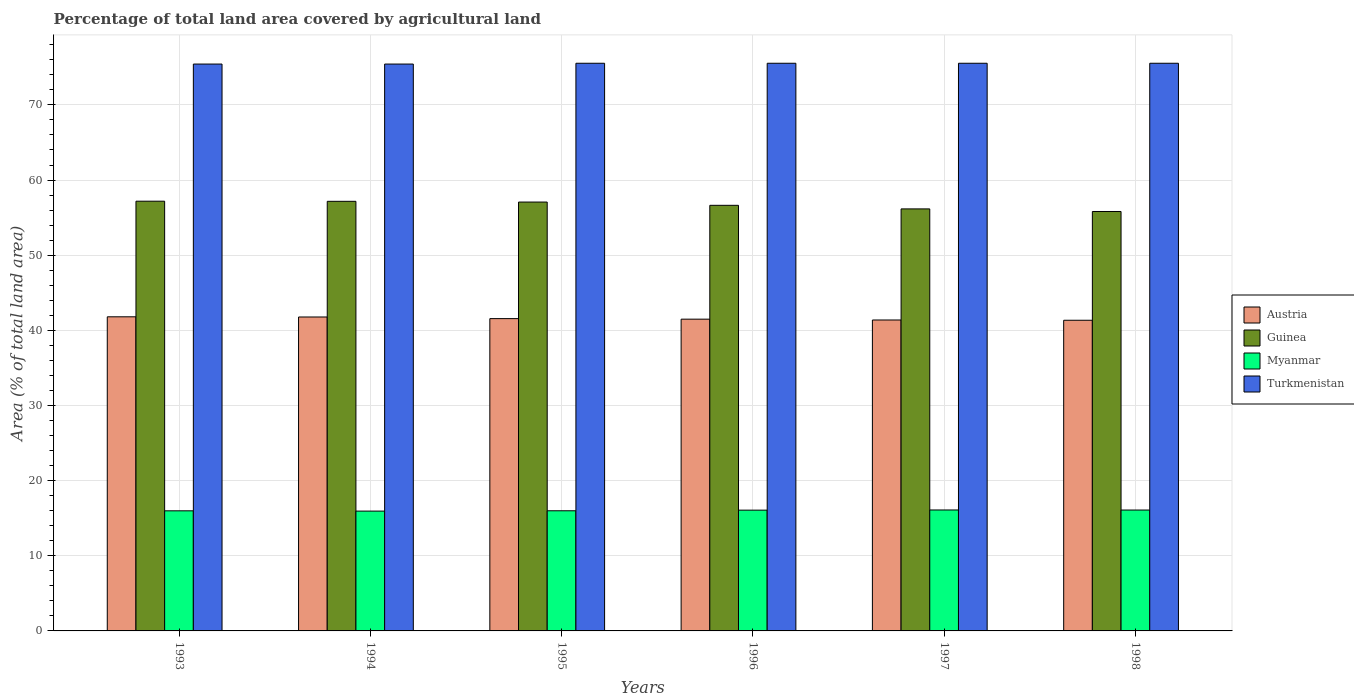How many different coloured bars are there?
Make the answer very short. 4. Are the number of bars per tick equal to the number of legend labels?
Offer a very short reply. Yes. What is the label of the 5th group of bars from the left?
Provide a short and direct response. 1997. In how many cases, is the number of bars for a given year not equal to the number of legend labels?
Your response must be concise. 0. What is the percentage of agricultural land in Turkmenistan in 1996?
Keep it short and to the point. 75.54. Across all years, what is the maximum percentage of agricultural land in Turkmenistan?
Your response must be concise. 75.54. Across all years, what is the minimum percentage of agricultural land in Austria?
Make the answer very short. 41.34. In which year was the percentage of agricultural land in Turkmenistan minimum?
Your response must be concise. 1993. What is the total percentage of agricultural land in Turkmenistan in the graph?
Your response must be concise. 453.05. What is the difference between the percentage of agricultural land in Austria in 1994 and that in 1998?
Give a very brief answer. 0.44. What is the difference between the percentage of agricultural land in Turkmenistan in 1998 and the percentage of agricultural land in Guinea in 1994?
Make the answer very short. 18.37. What is the average percentage of agricultural land in Turkmenistan per year?
Give a very brief answer. 75.51. In the year 1996, what is the difference between the percentage of agricultural land in Guinea and percentage of agricultural land in Austria?
Your answer should be compact. 15.15. In how many years, is the percentage of agricultural land in Guinea greater than 2 %?
Provide a succinct answer. 6. What is the ratio of the percentage of agricultural land in Guinea in 1997 to that in 1998?
Provide a short and direct response. 1.01. Is the percentage of agricultural land in Guinea in 1997 less than that in 1998?
Your answer should be very brief. No. What is the difference between the highest and the second highest percentage of agricultural land in Turkmenistan?
Your answer should be very brief. 0. What is the difference between the highest and the lowest percentage of agricultural land in Turkmenistan?
Give a very brief answer. 0.11. In how many years, is the percentage of agricultural land in Myanmar greater than the average percentage of agricultural land in Myanmar taken over all years?
Offer a terse response. 3. Is the sum of the percentage of agricultural land in Myanmar in 1993 and 1998 greater than the maximum percentage of agricultural land in Turkmenistan across all years?
Provide a short and direct response. No. Is it the case that in every year, the sum of the percentage of agricultural land in Guinea and percentage of agricultural land in Austria is greater than the sum of percentage of agricultural land in Turkmenistan and percentage of agricultural land in Myanmar?
Your response must be concise. Yes. What does the 2nd bar from the left in 1995 represents?
Your answer should be compact. Guinea. What does the 3rd bar from the right in 1998 represents?
Provide a succinct answer. Guinea. How many bars are there?
Your answer should be compact. 24. How many years are there in the graph?
Offer a terse response. 6. What is the difference between two consecutive major ticks on the Y-axis?
Ensure brevity in your answer.  10. Does the graph contain any zero values?
Provide a succinct answer. No. Does the graph contain grids?
Your answer should be compact. Yes. Where does the legend appear in the graph?
Offer a terse response. Center right. How many legend labels are there?
Give a very brief answer. 4. How are the legend labels stacked?
Provide a succinct answer. Vertical. What is the title of the graph?
Give a very brief answer. Percentage of total land area covered by agricultural land. What is the label or title of the X-axis?
Provide a short and direct response. Years. What is the label or title of the Y-axis?
Offer a terse response. Area (% of total land area). What is the Area (% of total land area) in Austria in 1993?
Offer a very short reply. 41.8. What is the Area (% of total land area) of Guinea in 1993?
Your answer should be very brief. 57.19. What is the Area (% of total land area) in Myanmar in 1993?
Keep it short and to the point. 15.98. What is the Area (% of total land area) of Turkmenistan in 1993?
Offer a terse response. 75.44. What is the Area (% of total land area) of Austria in 1994?
Provide a succinct answer. 41.78. What is the Area (% of total land area) of Guinea in 1994?
Your answer should be compact. 57.17. What is the Area (% of total land area) in Myanmar in 1994?
Your response must be concise. 15.95. What is the Area (% of total land area) of Turkmenistan in 1994?
Ensure brevity in your answer.  75.44. What is the Area (% of total land area) in Austria in 1995?
Your response must be concise. 41.56. What is the Area (% of total land area) of Guinea in 1995?
Your answer should be very brief. 57.07. What is the Area (% of total land area) of Myanmar in 1995?
Your answer should be compact. 15.99. What is the Area (% of total land area) of Turkmenistan in 1995?
Provide a short and direct response. 75.54. What is the Area (% of total land area) of Austria in 1996?
Provide a short and direct response. 41.49. What is the Area (% of total land area) of Guinea in 1996?
Offer a very short reply. 56.64. What is the Area (% of total land area) in Myanmar in 1996?
Offer a terse response. 16.07. What is the Area (% of total land area) of Turkmenistan in 1996?
Provide a succinct answer. 75.54. What is the Area (% of total land area) of Austria in 1997?
Offer a very short reply. 41.38. What is the Area (% of total land area) in Guinea in 1997?
Provide a short and direct response. 56.16. What is the Area (% of total land area) in Myanmar in 1997?
Make the answer very short. 16.1. What is the Area (% of total land area) in Turkmenistan in 1997?
Give a very brief answer. 75.54. What is the Area (% of total land area) of Austria in 1998?
Your answer should be very brief. 41.34. What is the Area (% of total land area) of Guinea in 1998?
Provide a succinct answer. 55.82. What is the Area (% of total land area) of Myanmar in 1998?
Give a very brief answer. 16.09. What is the Area (% of total land area) of Turkmenistan in 1998?
Provide a succinct answer. 75.54. Across all years, what is the maximum Area (% of total land area) in Austria?
Your answer should be compact. 41.8. Across all years, what is the maximum Area (% of total land area) of Guinea?
Offer a terse response. 57.19. Across all years, what is the maximum Area (% of total land area) of Myanmar?
Provide a succinct answer. 16.1. Across all years, what is the maximum Area (% of total land area) in Turkmenistan?
Make the answer very short. 75.54. Across all years, what is the minimum Area (% of total land area) in Austria?
Your answer should be very brief. 41.34. Across all years, what is the minimum Area (% of total land area) in Guinea?
Your response must be concise. 55.82. Across all years, what is the minimum Area (% of total land area) in Myanmar?
Your answer should be very brief. 15.95. Across all years, what is the minimum Area (% of total land area) in Turkmenistan?
Offer a terse response. 75.44. What is the total Area (% of total land area) in Austria in the graph?
Your answer should be compact. 249.35. What is the total Area (% of total land area) in Guinea in the graph?
Your answer should be very brief. 340.05. What is the total Area (% of total land area) in Myanmar in the graph?
Offer a very short reply. 96.17. What is the total Area (% of total land area) in Turkmenistan in the graph?
Your answer should be compact. 453.05. What is the difference between the Area (% of total land area) of Austria in 1993 and that in 1994?
Keep it short and to the point. 0.02. What is the difference between the Area (% of total land area) of Guinea in 1993 and that in 1994?
Provide a short and direct response. 0.02. What is the difference between the Area (% of total land area) in Myanmar in 1993 and that in 1994?
Make the answer very short. 0.04. What is the difference between the Area (% of total land area) in Austria in 1993 and that in 1995?
Keep it short and to the point. 0.24. What is the difference between the Area (% of total land area) in Guinea in 1993 and that in 1995?
Offer a terse response. 0.11. What is the difference between the Area (% of total land area) of Myanmar in 1993 and that in 1995?
Your response must be concise. -0.01. What is the difference between the Area (% of total land area) in Turkmenistan in 1993 and that in 1995?
Keep it short and to the point. -0.11. What is the difference between the Area (% of total land area) in Austria in 1993 and that in 1996?
Your response must be concise. 0.31. What is the difference between the Area (% of total land area) of Guinea in 1993 and that in 1996?
Ensure brevity in your answer.  0.55. What is the difference between the Area (% of total land area) in Myanmar in 1993 and that in 1996?
Your answer should be very brief. -0.09. What is the difference between the Area (% of total land area) of Turkmenistan in 1993 and that in 1996?
Make the answer very short. -0.11. What is the difference between the Area (% of total land area) of Austria in 1993 and that in 1997?
Offer a terse response. 0.42. What is the difference between the Area (% of total land area) of Guinea in 1993 and that in 1997?
Ensure brevity in your answer.  1.03. What is the difference between the Area (% of total land area) of Myanmar in 1993 and that in 1997?
Keep it short and to the point. -0.11. What is the difference between the Area (% of total land area) in Turkmenistan in 1993 and that in 1997?
Your answer should be very brief. -0.11. What is the difference between the Area (% of total land area) of Austria in 1993 and that in 1998?
Offer a very short reply. 0.46. What is the difference between the Area (% of total land area) of Guinea in 1993 and that in 1998?
Your response must be concise. 1.37. What is the difference between the Area (% of total land area) in Myanmar in 1993 and that in 1998?
Offer a terse response. -0.1. What is the difference between the Area (% of total land area) in Turkmenistan in 1993 and that in 1998?
Your answer should be very brief. -0.11. What is the difference between the Area (% of total land area) in Austria in 1994 and that in 1995?
Provide a succinct answer. 0.22. What is the difference between the Area (% of total land area) in Guinea in 1994 and that in 1995?
Provide a succinct answer. 0.1. What is the difference between the Area (% of total land area) in Myanmar in 1994 and that in 1995?
Offer a very short reply. -0.04. What is the difference between the Area (% of total land area) in Turkmenistan in 1994 and that in 1995?
Your answer should be compact. -0.11. What is the difference between the Area (% of total land area) in Austria in 1994 and that in 1996?
Offer a very short reply. 0.29. What is the difference between the Area (% of total land area) of Guinea in 1994 and that in 1996?
Ensure brevity in your answer.  0.53. What is the difference between the Area (% of total land area) in Myanmar in 1994 and that in 1996?
Offer a terse response. -0.13. What is the difference between the Area (% of total land area) of Turkmenistan in 1994 and that in 1996?
Your answer should be compact. -0.11. What is the difference between the Area (% of total land area) in Austria in 1994 and that in 1997?
Your answer should be compact. 0.4. What is the difference between the Area (% of total land area) in Guinea in 1994 and that in 1997?
Offer a very short reply. 1.01. What is the difference between the Area (% of total land area) in Turkmenistan in 1994 and that in 1997?
Give a very brief answer. -0.11. What is the difference between the Area (% of total land area) in Austria in 1994 and that in 1998?
Your answer should be compact. 0.44. What is the difference between the Area (% of total land area) of Guinea in 1994 and that in 1998?
Your answer should be very brief. 1.36. What is the difference between the Area (% of total land area) in Myanmar in 1994 and that in 1998?
Your answer should be compact. -0.14. What is the difference between the Area (% of total land area) in Turkmenistan in 1994 and that in 1998?
Keep it short and to the point. -0.11. What is the difference between the Area (% of total land area) of Austria in 1995 and that in 1996?
Offer a terse response. 0.07. What is the difference between the Area (% of total land area) in Guinea in 1995 and that in 1996?
Your answer should be very brief. 0.44. What is the difference between the Area (% of total land area) in Myanmar in 1995 and that in 1996?
Ensure brevity in your answer.  -0.08. What is the difference between the Area (% of total land area) of Turkmenistan in 1995 and that in 1996?
Make the answer very short. 0. What is the difference between the Area (% of total land area) in Austria in 1995 and that in 1997?
Offer a terse response. 0.18. What is the difference between the Area (% of total land area) of Guinea in 1995 and that in 1997?
Offer a terse response. 0.91. What is the difference between the Area (% of total land area) in Myanmar in 1995 and that in 1997?
Keep it short and to the point. -0.11. What is the difference between the Area (% of total land area) of Turkmenistan in 1995 and that in 1997?
Ensure brevity in your answer.  0. What is the difference between the Area (% of total land area) of Austria in 1995 and that in 1998?
Provide a short and direct response. 0.22. What is the difference between the Area (% of total land area) in Guinea in 1995 and that in 1998?
Offer a terse response. 1.26. What is the difference between the Area (% of total land area) in Myanmar in 1995 and that in 1998?
Ensure brevity in your answer.  -0.1. What is the difference between the Area (% of total land area) of Turkmenistan in 1995 and that in 1998?
Your response must be concise. 0. What is the difference between the Area (% of total land area) in Austria in 1996 and that in 1997?
Give a very brief answer. 0.11. What is the difference between the Area (% of total land area) of Guinea in 1996 and that in 1997?
Offer a very short reply. 0.48. What is the difference between the Area (% of total land area) of Myanmar in 1996 and that in 1997?
Your response must be concise. -0.02. What is the difference between the Area (% of total land area) in Austria in 1996 and that in 1998?
Provide a succinct answer. 0.15. What is the difference between the Area (% of total land area) of Guinea in 1996 and that in 1998?
Provide a succinct answer. 0.82. What is the difference between the Area (% of total land area) in Myanmar in 1996 and that in 1998?
Provide a succinct answer. -0.01. What is the difference between the Area (% of total land area) in Turkmenistan in 1996 and that in 1998?
Keep it short and to the point. 0. What is the difference between the Area (% of total land area) in Austria in 1997 and that in 1998?
Provide a succinct answer. 0.04. What is the difference between the Area (% of total land area) of Guinea in 1997 and that in 1998?
Your answer should be compact. 0.35. What is the difference between the Area (% of total land area) of Myanmar in 1997 and that in 1998?
Ensure brevity in your answer.  0.01. What is the difference between the Area (% of total land area) of Austria in 1993 and the Area (% of total land area) of Guinea in 1994?
Ensure brevity in your answer.  -15.37. What is the difference between the Area (% of total land area) in Austria in 1993 and the Area (% of total land area) in Myanmar in 1994?
Provide a short and direct response. 25.86. What is the difference between the Area (% of total land area) of Austria in 1993 and the Area (% of total land area) of Turkmenistan in 1994?
Your answer should be very brief. -33.63. What is the difference between the Area (% of total land area) of Guinea in 1993 and the Area (% of total land area) of Myanmar in 1994?
Your response must be concise. 41.24. What is the difference between the Area (% of total land area) of Guinea in 1993 and the Area (% of total land area) of Turkmenistan in 1994?
Your answer should be compact. -18.25. What is the difference between the Area (% of total land area) in Myanmar in 1993 and the Area (% of total land area) in Turkmenistan in 1994?
Offer a very short reply. -59.45. What is the difference between the Area (% of total land area) in Austria in 1993 and the Area (% of total land area) in Guinea in 1995?
Ensure brevity in your answer.  -15.27. What is the difference between the Area (% of total land area) in Austria in 1993 and the Area (% of total land area) in Myanmar in 1995?
Ensure brevity in your answer.  25.81. What is the difference between the Area (% of total land area) of Austria in 1993 and the Area (% of total land area) of Turkmenistan in 1995?
Provide a succinct answer. -33.74. What is the difference between the Area (% of total land area) in Guinea in 1993 and the Area (% of total land area) in Myanmar in 1995?
Provide a succinct answer. 41.2. What is the difference between the Area (% of total land area) in Guinea in 1993 and the Area (% of total land area) in Turkmenistan in 1995?
Provide a succinct answer. -18.36. What is the difference between the Area (% of total land area) in Myanmar in 1993 and the Area (% of total land area) in Turkmenistan in 1995?
Your answer should be compact. -59.56. What is the difference between the Area (% of total land area) of Austria in 1993 and the Area (% of total land area) of Guinea in 1996?
Ensure brevity in your answer.  -14.84. What is the difference between the Area (% of total land area) in Austria in 1993 and the Area (% of total land area) in Myanmar in 1996?
Offer a terse response. 25.73. What is the difference between the Area (% of total land area) in Austria in 1993 and the Area (% of total land area) in Turkmenistan in 1996?
Your answer should be compact. -33.74. What is the difference between the Area (% of total land area) of Guinea in 1993 and the Area (% of total land area) of Myanmar in 1996?
Keep it short and to the point. 41.11. What is the difference between the Area (% of total land area) in Guinea in 1993 and the Area (% of total land area) in Turkmenistan in 1996?
Provide a short and direct response. -18.36. What is the difference between the Area (% of total land area) of Myanmar in 1993 and the Area (% of total land area) of Turkmenistan in 1996?
Keep it short and to the point. -59.56. What is the difference between the Area (% of total land area) in Austria in 1993 and the Area (% of total land area) in Guinea in 1997?
Give a very brief answer. -14.36. What is the difference between the Area (% of total land area) in Austria in 1993 and the Area (% of total land area) in Myanmar in 1997?
Provide a succinct answer. 25.71. What is the difference between the Area (% of total land area) in Austria in 1993 and the Area (% of total land area) in Turkmenistan in 1997?
Ensure brevity in your answer.  -33.74. What is the difference between the Area (% of total land area) of Guinea in 1993 and the Area (% of total land area) of Myanmar in 1997?
Your answer should be very brief. 41.09. What is the difference between the Area (% of total land area) in Guinea in 1993 and the Area (% of total land area) in Turkmenistan in 1997?
Ensure brevity in your answer.  -18.36. What is the difference between the Area (% of total land area) of Myanmar in 1993 and the Area (% of total land area) of Turkmenistan in 1997?
Offer a terse response. -59.56. What is the difference between the Area (% of total land area) of Austria in 1993 and the Area (% of total land area) of Guinea in 1998?
Provide a short and direct response. -14.01. What is the difference between the Area (% of total land area) of Austria in 1993 and the Area (% of total land area) of Myanmar in 1998?
Give a very brief answer. 25.72. What is the difference between the Area (% of total land area) in Austria in 1993 and the Area (% of total land area) in Turkmenistan in 1998?
Offer a very short reply. -33.74. What is the difference between the Area (% of total land area) of Guinea in 1993 and the Area (% of total land area) of Myanmar in 1998?
Provide a short and direct response. 41.1. What is the difference between the Area (% of total land area) of Guinea in 1993 and the Area (% of total land area) of Turkmenistan in 1998?
Provide a succinct answer. -18.36. What is the difference between the Area (% of total land area) in Myanmar in 1993 and the Area (% of total land area) in Turkmenistan in 1998?
Your response must be concise. -59.56. What is the difference between the Area (% of total land area) in Austria in 1994 and the Area (% of total land area) in Guinea in 1995?
Provide a succinct answer. -15.3. What is the difference between the Area (% of total land area) of Austria in 1994 and the Area (% of total land area) of Myanmar in 1995?
Give a very brief answer. 25.79. What is the difference between the Area (% of total land area) of Austria in 1994 and the Area (% of total land area) of Turkmenistan in 1995?
Your answer should be compact. -33.77. What is the difference between the Area (% of total land area) of Guinea in 1994 and the Area (% of total land area) of Myanmar in 1995?
Your answer should be very brief. 41.18. What is the difference between the Area (% of total land area) in Guinea in 1994 and the Area (% of total land area) in Turkmenistan in 1995?
Provide a succinct answer. -18.37. What is the difference between the Area (% of total land area) in Myanmar in 1994 and the Area (% of total land area) in Turkmenistan in 1995?
Make the answer very short. -59.6. What is the difference between the Area (% of total land area) in Austria in 1994 and the Area (% of total land area) in Guinea in 1996?
Offer a very short reply. -14.86. What is the difference between the Area (% of total land area) in Austria in 1994 and the Area (% of total land area) in Myanmar in 1996?
Offer a terse response. 25.71. What is the difference between the Area (% of total land area) of Austria in 1994 and the Area (% of total land area) of Turkmenistan in 1996?
Provide a short and direct response. -33.77. What is the difference between the Area (% of total land area) of Guinea in 1994 and the Area (% of total land area) of Myanmar in 1996?
Give a very brief answer. 41.1. What is the difference between the Area (% of total land area) of Guinea in 1994 and the Area (% of total land area) of Turkmenistan in 1996?
Keep it short and to the point. -18.37. What is the difference between the Area (% of total land area) in Myanmar in 1994 and the Area (% of total land area) in Turkmenistan in 1996?
Keep it short and to the point. -59.6. What is the difference between the Area (% of total land area) of Austria in 1994 and the Area (% of total land area) of Guinea in 1997?
Ensure brevity in your answer.  -14.38. What is the difference between the Area (% of total land area) in Austria in 1994 and the Area (% of total land area) in Myanmar in 1997?
Make the answer very short. 25.68. What is the difference between the Area (% of total land area) in Austria in 1994 and the Area (% of total land area) in Turkmenistan in 1997?
Your answer should be very brief. -33.77. What is the difference between the Area (% of total land area) in Guinea in 1994 and the Area (% of total land area) in Myanmar in 1997?
Provide a succinct answer. 41.08. What is the difference between the Area (% of total land area) of Guinea in 1994 and the Area (% of total land area) of Turkmenistan in 1997?
Offer a terse response. -18.37. What is the difference between the Area (% of total land area) of Myanmar in 1994 and the Area (% of total land area) of Turkmenistan in 1997?
Your response must be concise. -59.6. What is the difference between the Area (% of total land area) of Austria in 1994 and the Area (% of total land area) of Guinea in 1998?
Offer a terse response. -14.04. What is the difference between the Area (% of total land area) of Austria in 1994 and the Area (% of total land area) of Myanmar in 1998?
Keep it short and to the point. 25.69. What is the difference between the Area (% of total land area) in Austria in 1994 and the Area (% of total land area) in Turkmenistan in 1998?
Provide a succinct answer. -33.77. What is the difference between the Area (% of total land area) in Guinea in 1994 and the Area (% of total land area) in Myanmar in 1998?
Your answer should be very brief. 41.08. What is the difference between the Area (% of total land area) in Guinea in 1994 and the Area (% of total land area) in Turkmenistan in 1998?
Offer a terse response. -18.37. What is the difference between the Area (% of total land area) of Myanmar in 1994 and the Area (% of total land area) of Turkmenistan in 1998?
Offer a terse response. -59.6. What is the difference between the Area (% of total land area) of Austria in 1995 and the Area (% of total land area) of Guinea in 1996?
Your answer should be very brief. -15.08. What is the difference between the Area (% of total land area) in Austria in 1995 and the Area (% of total land area) in Myanmar in 1996?
Make the answer very short. 25.49. What is the difference between the Area (% of total land area) in Austria in 1995 and the Area (% of total land area) in Turkmenistan in 1996?
Keep it short and to the point. -33.98. What is the difference between the Area (% of total land area) of Guinea in 1995 and the Area (% of total land area) of Myanmar in 1996?
Give a very brief answer. 41. What is the difference between the Area (% of total land area) in Guinea in 1995 and the Area (% of total land area) in Turkmenistan in 1996?
Give a very brief answer. -18.47. What is the difference between the Area (% of total land area) in Myanmar in 1995 and the Area (% of total land area) in Turkmenistan in 1996?
Offer a very short reply. -59.55. What is the difference between the Area (% of total land area) in Austria in 1995 and the Area (% of total land area) in Guinea in 1997?
Provide a succinct answer. -14.6. What is the difference between the Area (% of total land area) of Austria in 1995 and the Area (% of total land area) of Myanmar in 1997?
Your response must be concise. 25.46. What is the difference between the Area (% of total land area) in Austria in 1995 and the Area (% of total land area) in Turkmenistan in 1997?
Your response must be concise. -33.98. What is the difference between the Area (% of total land area) in Guinea in 1995 and the Area (% of total land area) in Myanmar in 1997?
Provide a short and direct response. 40.98. What is the difference between the Area (% of total land area) in Guinea in 1995 and the Area (% of total land area) in Turkmenistan in 1997?
Your answer should be very brief. -18.47. What is the difference between the Area (% of total land area) of Myanmar in 1995 and the Area (% of total land area) of Turkmenistan in 1997?
Keep it short and to the point. -59.55. What is the difference between the Area (% of total land area) in Austria in 1995 and the Area (% of total land area) in Guinea in 1998?
Provide a short and direct response. -14.26. What is the difference between the Area (% of total land area) in Austria in 1995 and the Area (% of total land area) in Myanmar in 1998?
Provide a succinct answer. 25.47. What is the difference between the Area (% of total land area) in Austria in 1995 and the Area (% of total land area) in Turkmenistan in 1998?
Your response must be concise. -33.98. What is the difference between the Area (% of total land area) of Guinea in 1995 and the Area (% of total land area) of Myanmar in 1998?
Your response must be concise. 40.99. What is the difference between the Area (% of total land area) of Guinea in 1995 and the Area (% of total land area) of Turkmenistan in 1998?
Your answer should be compact. -18.47. What is the difference between the Area (% of total land area) in Myanmar in 1995 and the Area (% of total land area) in Turkmenistan in 1998?
Ensure brevity in your answer.  -59.55. What is the difference between the Area (% of total land area) of Austria in 1996 and the Area (% of total land area) of Guinea in 1997?
Provide a short and direct response. -14.67. What is the difference between the Area (% of total land area) in Austria in 1996 and the Area (% of total land area) in Myanmar in 1997?
Keep it short and to the point. 25.39. What is the difference between the Area (% of total land area) in Austria in 1996 and the Area (% of total land area) in Turkmenistan in 1997?
Your answer should be very brief. -34.06. What is the difference between the Area (% of total land area) of Guinea in 1996 and the Area (% of total land area) of Myanmar in 1997?
Give a very brief answer. 40.54. What is the difference between the Area (% of total land area) of Guinea in 1996 and the Area (% of total land area) of Turkmenistan in 1997?
Offer a terse response. -18.91. What is the difference between the Area (% of total land area) of Myanmar in 1996 and the Area (% of total land area) of Turkmenistan in 1997?
Make the answer very short. -59.47. What is the difference between the Area (% of total land area) of Austria in 1996 and the Area (% of total land area) of Guinea in 1998?
Offer a very short reply. -14.33. What is the difference between the Area (% of total land area) of Austria in 1996 and the Area (% of total land area) of Myanmar in 1998?
Provide a succinct answer. 25.4. What is the difference between the Area (% of total land area) of Austria in 1996 and the Area (% of total land area) of Turkmenistan in 1998?
Offer a terse response. -34.06. What is the difference between the Area (% of total land area) of Guinea in 1996 and the Area (% of total land area) of Myanmar in 1998?
Keep it short and to the point. 40.55. What is the difference between the Area (% of total land area) of Guinea in 1996 and the Area (% of total land area) of Turkmenistan in 1998?
Provide a short and direct response. -18.91. What is the difference between the Area (% of total land area) in Myanmar in 1996 and the Area (% of total land area) in Turkmenistan in 1998?
Provide a succinct answer. -59.47. What is the difference between the Area (% of total land area) of Austria in 1997 and the Area (% of total land area) of Guinea in 1998?
Make the answer very short. -14.44. What is the difference between the Area (% of total land area) in Austria in 1997 and the Area (% of total land area) in Myanmar in 1998?
Your response must be concise. 25.29. What is the difference between the Area (% of total land area) in Austria in 1997 and the Area (% of total land area) in Turkmenistan in 1998?
Offer a terse response. -34.17. What is the difference between the Area (% of total land area) of Guinea in 1997 and the Area (% of total land area) of Myanmar in 1998?
Ensure brevity in your answer.  40.08. What is the difference between the Area (% of total land area) of Guinea in 1997 and the Area (% of total land area) of Turkmenistan in 1998?
Give a very brief answer. -19.38. What is the difference between the Area (% of total land area) in Myanmar in 1997 and the Area (% of total land area) in Turkmenistan in 1998?
Make the answer very short. -59.45. What is the average Area (% of total land area) of Austria per year?
Give a very brief answer. 41.56. What is the average Area (% of total land area) of Guinea per year?
Provide a succinct answer. 56.67. What is the average Area (% of total land area) in Myanmar per year?
Your answer should be very brief. 16.03. What is the average Area (% of total land area) in Turkmenistan per year?
Offer a very short reply. 75.51. In the year 1993, what is the difference between the Area (% of total land area) of Austria and Area (% of total land area) of Guinea?
Give a very brief answer. -15.39. In the year 1993, what is the difference between the Area (% of total land area) in Austria and Area (% of total land area) in Myanmar?
Keep it short and to the point. 25.82. In the year 1993, what is the difference between the Area (% of total land area) in Austria and Area (% of total land area) in Turkmenistan?
Offer a very short reply. -33.63. In the year 1993, what is the difference between the Area (% of total land area) of Guinea and Area (% of total land area) of Myanmar?
Provide a succinct answer. 41.2. In the year 1993, what is the difference between the Area (% of total land area) in Guinea and Area (% of total land area) in Turkmenistan?
Offer a terse response. -18.25. In the year 1993, what is the difference between the Area (% of total land area) of Myanmar and Area (% of total land area) of Turkmenistan?
Offer a terse response. -59.45. In the year 1994, what is the difference between the Area (% of total land area) of Austria and Area (% of total land area) of Guinea?
Offer a terse response. -15.39. In the year 1994, what is the difference between the Area (% of total land area) of Austria and Area (% of total land area) of Myanmar?
Provide a succinct answer. 25.83. In the year 1994, what is the difference between the Area (% of total land area) in Austria and Area (% of total land area) in Turkmenistan?
Your answer should be very brief. -33.66. In the year 1994, what is the difference between the Area (% of total land area) of Guinea and Area (% of total land area) of Myanmar?
Offer a very short reply. 41.23. In the year 1994, what is the difference between the Area (% of total land area) in Guinea and Area (% of total land area) in Turkmenistan?
Your response must be concise. -18.27. In the year 1994, what is the difference between the Area (% of total land area) of Myanmar and Area (% of total land area) of Turkmenistan?
Offer a terse response. -59.49. In the year 1995, what is the difference between the Area (% of total land area) of Austria and Area (% of total land area) of Guinea?
Provide a succinct answer. -15.51. In the year 1995, what is the difference between the Area (% of total land area) of Austria and Area (% of total land area) of Myanmar?
Make the answer very short. 25.57. In the year 1995, what is the difference between the Area (% of total land area) in Austria and Area (% of total land area) in Turkmenistan?
Give a very brief answer. -33.98. In the year 1995, what is the difference between the Area (% of total land area) in Guinea and Area (% of total land area) in Myanmar?
Provide a short and direct response. 41.08. In the year 1995, what is the difference between the Area (% of total land area) in Guinea and Area (% of total land area) in Turkmenistan?
Give a very brief answer. -18.47. In the year 1995, what is the difference between the Area (% of total land area) of Myanmar and Area (% of total land area) of Turkmenistan?
Give a very brief answer. -59.55. In the year 1996, what is the difference between the Area (% of total land area) in Austria and Area (% of total land area) in Guinea?
Provide a succinct answer. -15.15. In the year 1996, what is the difference between the Area (% of total land area) of Austria and Area (% of total land area) of Myanmar?
Keep it short and to the point. 25.41. In the year 1996, what is the difference between the Area (% of total land area) in Austria and Area (% of total land area) in Turkmenistan?
Offer a very short reply. -34.06. In the year 1996, what is the difference between the Area (% of total land area) in Guinea and Area (% of total land area) in Myanmar?
Provide a succinct answer. 40.57. In the year 1996, what is the difference between the Area (% of total land area) of Guinea and Area (% of total land area) of Turkmenistan?
Your response must be concise. -18.91. In the year 1996, what is the difference between the Area (% of total land area) of Myanmar and Area (% of total land area) of Turkmenistan?
Offer a terse response. -59.47. In the year 1997, what is the difference between the Area (% of total land area) in Austria and Area (% of total land area) in Guinea?
Offer a very short reply. -14.78. In the year 1997, what is the difference between the Area (% of total land area) in Austria and Area (% of total land area) in Myanmar?
Offer a very short reply. 25.28. In the year 1997, what is the difference between the Area (% of total land area) of Austria and Area (% of total land area) of Turkmenistan?
Give a very brief answer. -34.17. In the year 1997, what is the difference between the Area (% of total land area) of Guinea and Area (% of total land area) of Myanmar?
Your answer should be very brief. 40.07. In the year 1997, what is the difference between the Area (% of total land area) of Guinea and Area (% of total land area) of Turkmenistan?
Offer a terse response. -19.38. In the year 1997, what is the difference between the Area (% of total land area) of Myanmar and Area (% of total land area) of Turkmenistan?
Ensure brevity in your answer.  -59.45. In the year 1998, what is the difference between the Area (% of total land area) in Austria and Area (% of total land area) in Guinea?
Offer a terse response. -14.47. In the year 1998, what is the difference between the Area (% of total land area) of Austria and Area (% of total land area) of Myanmar?
Ensure brevity in your answer.  25.26. In the year 1998, what is the difference between the Area (% of total land area) of Austria and Area (% of total land area) of Turkmenistan?
Provide a short and direct response. -34.2. In the year 1998, what is the difference between the Area (% of total land area) in Guinea and Area (% of total land area) in Myanmar?
Keep it short and to the point. 39.73. In the year 1998, what is the difference between the Area (% of total land area) in Guinea and Area (% of total land area) in Turkmenistan?
Your response must be concise. -19.73. In the year 1998, what is the difference between the Area (% of total land area) in Myanmar and Area (% of total land area) in Turkmenistan?
Offer a terse response. -59.46. What is the ratio of the Area (% of total land area) of Myanmar in 1993 to that in 1994?
Offer a terse response. 1. What is the ratio of the Area (% of total land area) of Turkmenistan in 1993 to that in 1994?
Offer a very short reply. 1. What is the ratio of the Area (% of total land area) of Turkmenistan in 1993 to that in 1995?
Your answer should be compact. 1. What is the ratio of the Area (% of total land area) in Austria in 1993 to that in 1996?
Keep it short and to the point. 1.01. What is the ratio of the Area (% of total land area) in Guinea in 1993 to that in 1996?
Your response must be concise. 1.01. What is the ratio of the Area (% of total land area) in Myanmar in 1993 to that in 1996?
Your answer should be compact. 0.99. What is the ratio of the Area (% of total land area) in Austria in 1993 to that in 1997?
Your answer should be compact. 1.01. What is the ratio of the Area (% of total land area) in Guinea in 1993 to that in 1997?
Your answer should be very brief. 1.02. What is the ratio of the Area (% of total land area) in Austria in 1993 to that in 1998?
Your answer should be compact. 1.01. What is the ratio of the Area (% of total land area) of Guinea in 1993 to that in 1998?
Offer a terse response. 1.02. What is the ratio of the Area (% of total land area) in Austria in 1994 to that in 1995?
Offer a very short reply. 1.01. What is the ratio of the Area (% of total land area) of Myanmar in 1994 to that in 1995?
Make the answer very short. 1. What is the ratio of the Area (% of total land area) in Guinea in 1994 to that in 1996?
Provide a short and direct response. 1.01. What is the ratio of the Area (% of total land area) in Turkmenistan in 1994 to that in 1996?
Offer a very short reply. 1. What is the ratio of the Area (% of total land area) in Austria in 1994 to that in 1997?
Your answer should be very brief. 1.01. What is the ratio of the Area (% of total land area) in Myanmar in 1994 to that in 1997?
Your answer should be compact. 0.99. What is the ratio of the Area (% of total land area) in Austria in 1994 to that in 1998?
Make the answer very short. 1.01. What is the ratio of the Area (% of total land area) of Guinea in 1994 to that in 1998?
Make the answer very short. 1.02. What is the ratio of the Area (% of total land area) in Turkmenistan in 1994 to that in 1998?
Offer a terse response. 1. What is the ratio of the Area (% of total land area) in Guinea in 1995 to that in 1996?
Make the answer very short. 1.01. What is the ratio of the Area (% of total land area) of Turkmenistan in 1995 to that in 1996?
Ensure brevity in your answer.  1. What is the ratio of the Area (% of total land area) in Austria in 1995 to that in 1997?
Your answer should be compact. 1. What is the ratio of the Area (% of total land area) in Guinea in 1995 to that in 1997?
Ensure brevity in your answer.  1.02. What is the ratio of the Area (% of total land area) of Myanmar in 1995 to that in 1997?
Offer a very short reply. 0.99. What is the ratio of the Area (% of total land area) in Turkmenistan in 1995 to that in 1997?
Your answer should be compact. 1. What is the ratio of the Area (% of total land area) of Guinea in 1995 to that in 1998?
Offer a very short reply. 1.02. What is the ratio of the Area (% of total land area) of Myanmar in 1995 to that in 1998?
Your response must be concise. 0.99. What is the ratio of the Area (% of total land area) of Turkmenistan in 1995 to that in 1998?
Your response must be concise. 1. What is the ratio of the Area (% of total land area) of Guinea in 1996 to that in 1997?
Offer a very short reply. 1.01. What is the ratio of the Area (% of total land area) in Guinea in 1996 to that in 1998?
Make the answer very short. 1.01. What is the ratio of the Area (% of total land area) in Myanmar in 1996 to that in 1998?
Provide a succinct answer. 1. What is the ratio of the Area (% of total land area) in Austria in 1997 to that in 1998?
Offer a terse response. 1. What is the ratio of the Area (% of total land area) of Myanmar in 1997 to that in 1998?
Your answer should be compact. 1. What is the ratio of the Area (% of total land area) in Turkmenistan in 1997 to that in 1998?
Ensure brevity in your answer.  1. What is the difference between the highest and the second highest Area (% of total land area) in Austria?
Provide a succinct answer. 0.02. What is the difference between the highest and the second highest Area (% of total land area) in Guinea?
Keep it short and to the point. 0.02. What is the difference between the highest and the second highest Area (% of total land area) of Myanmar?
Make the answer very short. 0.01. What is the difference between the highest and the lowest Area (% of total land area) of Austria?
Provide a short and direct response. 0.46. What is the difference between the highest and the lowest Area (% of total land area) of Guinea?
Provide a short and direct response. 1.37. What is the difference between the highest and the lowest Area (% of total land area) in Myanmar?
Your answer should be very brief. 0.15. What is the difference between the highest and the lowest Area (% of total land area) in Turkmenistan?
Your answer should be compact. 0.11. 